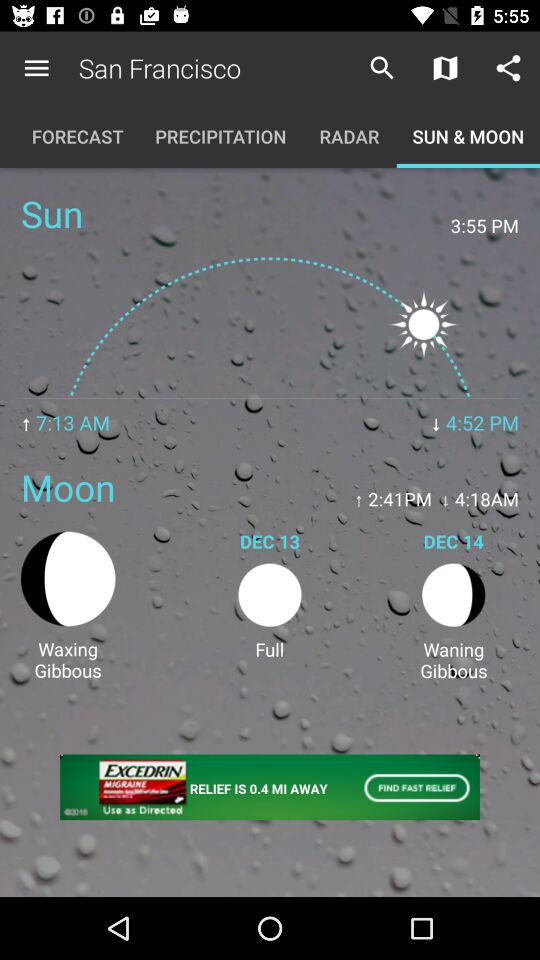What is the moon phase on December 13? There will be a full moon on December 13. 